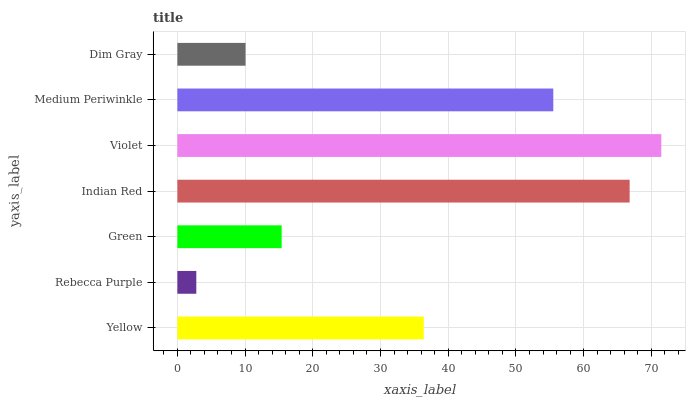Is Rebecca Purple the minimum?
Answer yes or no. Yes. Is Violet the maximum?
Answer yes or no. Yes. Is Green the minimum?
Answer yes or no. No. Is Green the maximum?
Answer yes or no. No. Is Green greater than Rebecca Purple?
Answer yes or no. Yes. Is Rebecca Purple less than Green?
Answer yes or no. Yes. Is Rebecca Purple greater than Green?
Answer yes or no. No. Is Green less than Rebecca Purple?
Answer yes or no. No. Is Yellow the high median?
Answer yes or no. Yes. Is Yellow the low median?
Answer yes or no. Yes. Is Indian Red the high median?
Answer yes or no. No. Is Rebecca Purple the low median?
Answer yes or no. No. 